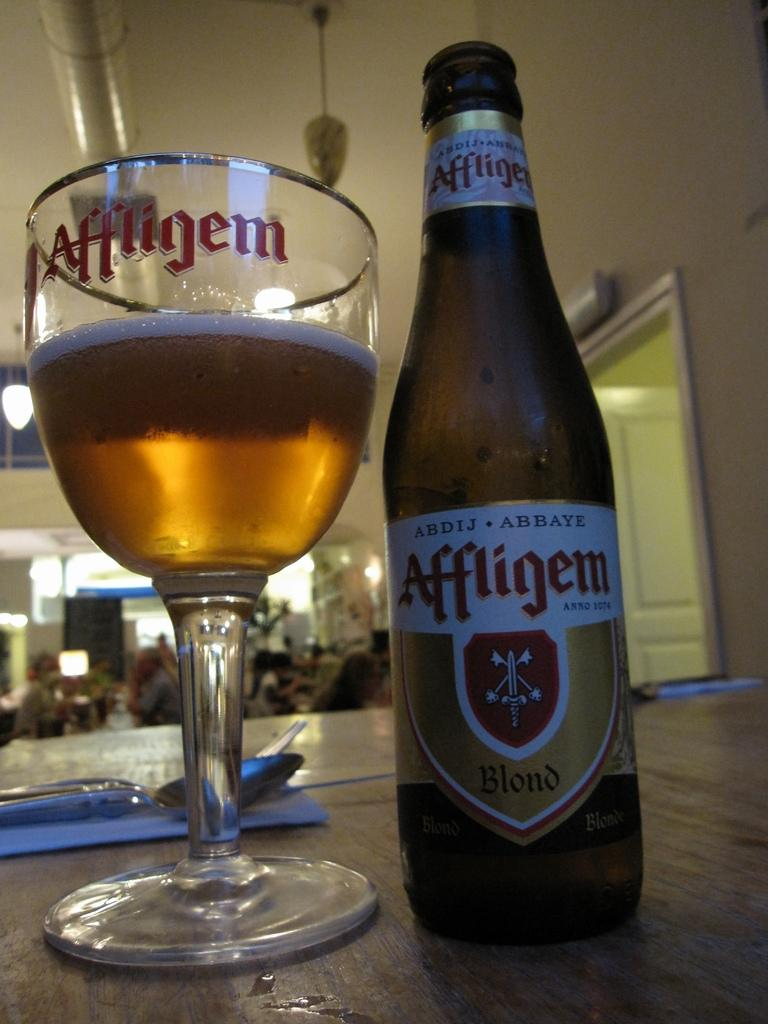<image>
Give a short and clear explanation of the subsequent image. a glass and bottle of Affligem Blond on a table 